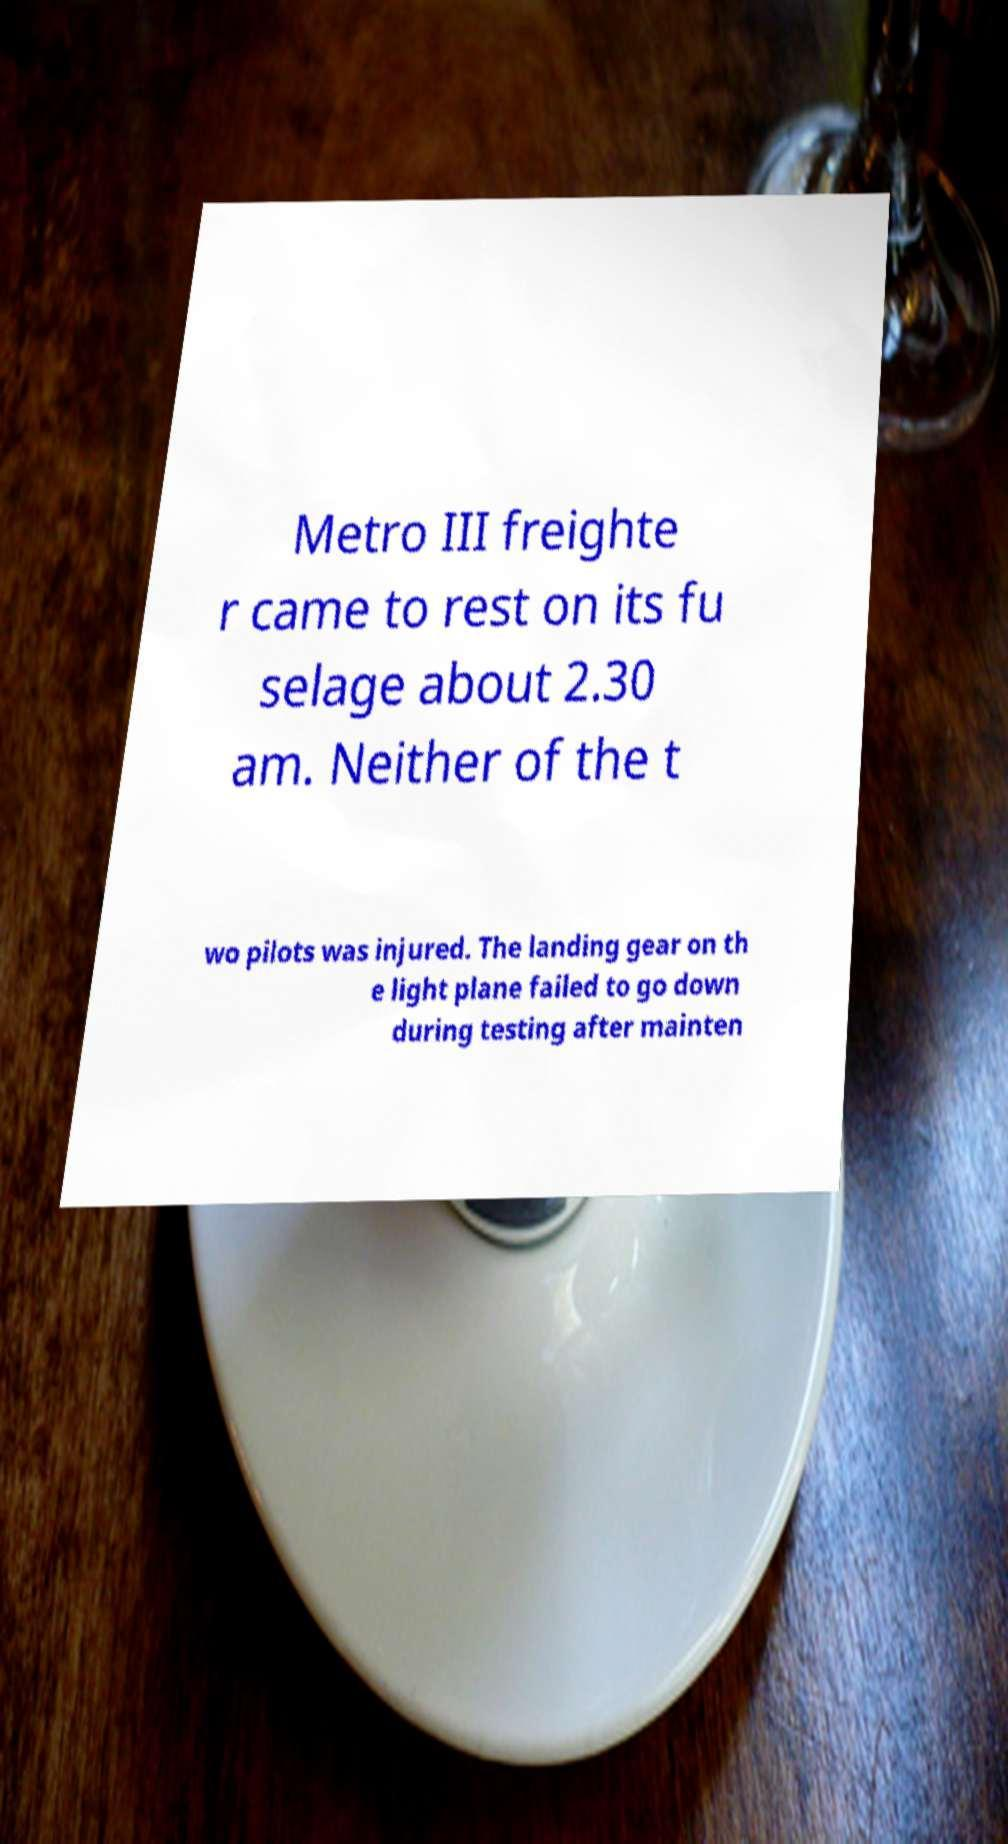Please identify and transcribe the text found in this image. Metro III freighte r came to rest on its fu selage about 2.30 am. Neither of the t wo pilots was injured. The landing gear on th e light plane failed to go down during testing after mainten 